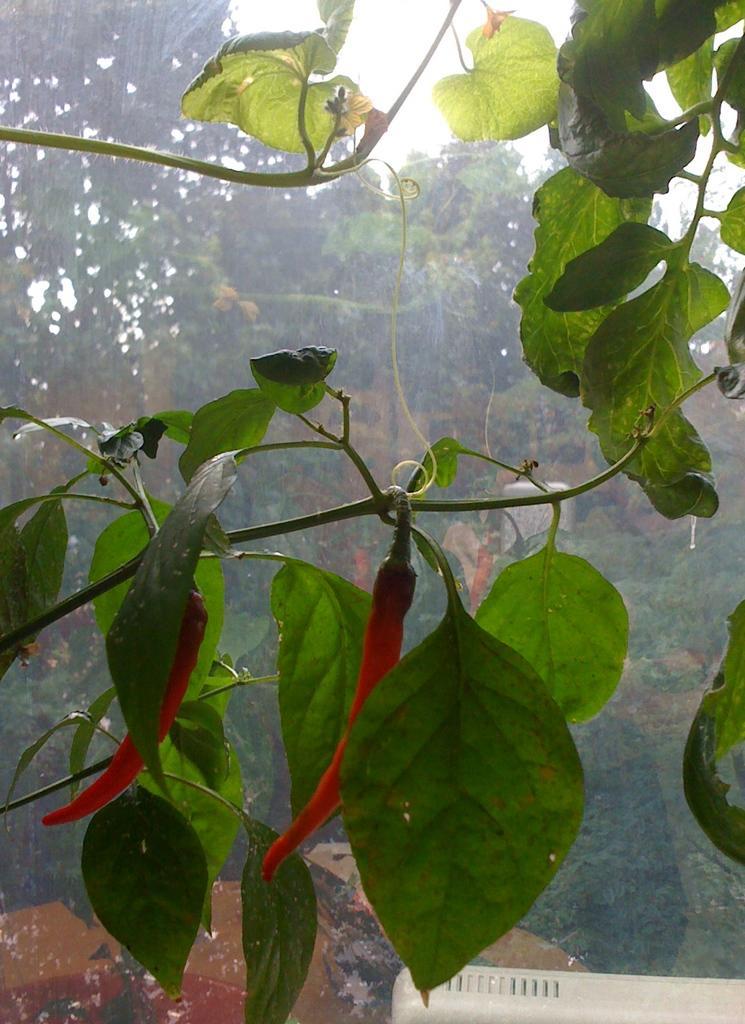Please provide a concise description of this image. In this image there is a creeper. There are leaves and red chilies to the stem. Behind the creeper there is a glass. Outside the class there are trees and the sky. 